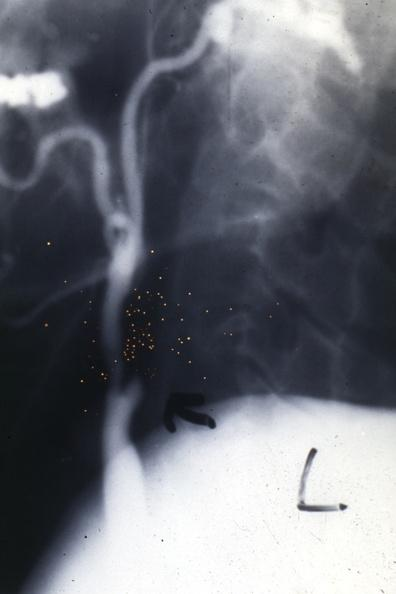what is present?
Answer the question using a single word or phrase. Aorta 